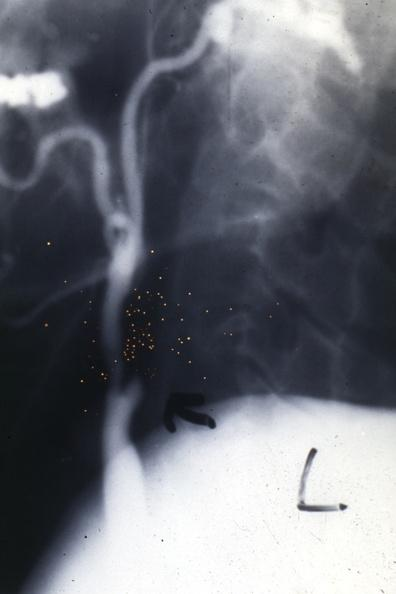what is present?
Answer the question using a single word or phrase. Aorta 